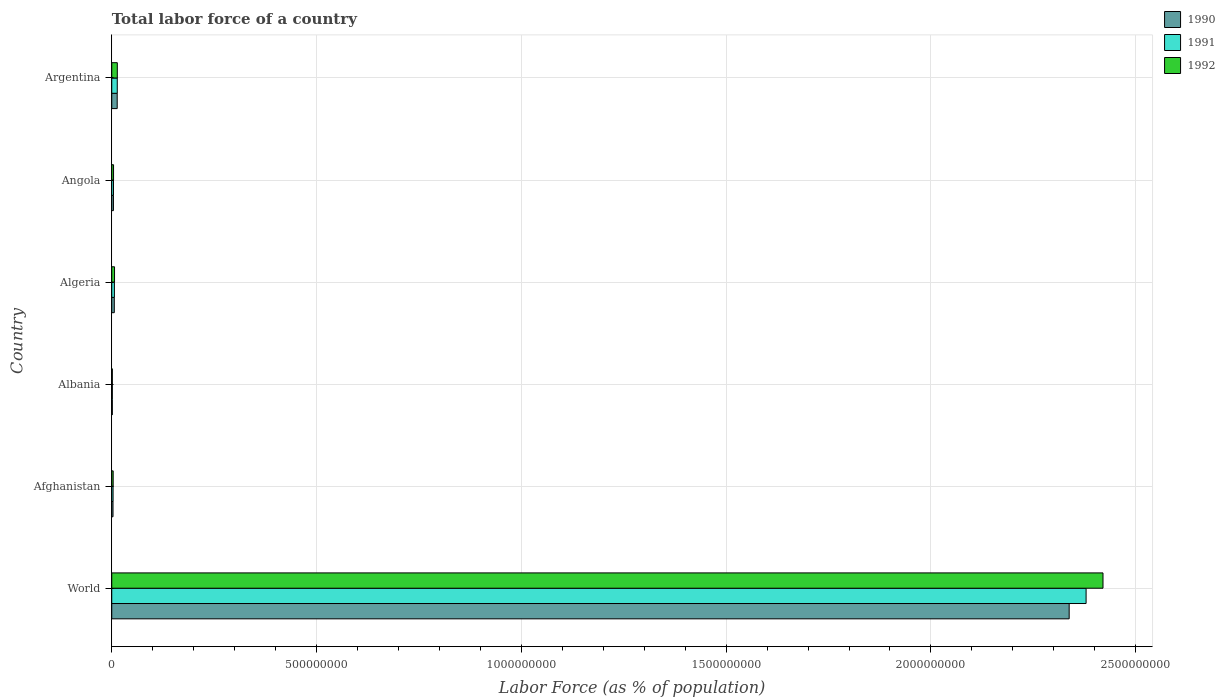How many different coloured bars are there?
Keep it short and to the point. 3. How many groups of bars are there?
Make the answer very short. 6. Are the number of bars per tick equal to the number of legend labels?
Your answer should be very brief. Yes. Are the number of bars on each tick of the Y-axis equal?
Offer a very short reply. Yes. How many bars are there on the 4th tick from the top?
Offer a terse response. 3. What is the label of the 4th group of bars from the top?
Ensure brevity in your answer.  Albania. What is the percentage of labor force in 1990 in World?
Your answer should be compact. 2.34e+09. Across all countries, what is the maximum percentage of labor force in 1992?
Your response must be concise. 2.42e+09. Across all countries, what is the minimum percentage of labor force in 1990?
Give a very brief answer. 1.42e+06. In which country was the percentage of labor force in 1992 minimum?
Provide a short and direct response. Albania. What is the total percentage of labor force in 1991 in the graph?
Your answer should be very brief. 2.41e+09. What is the difference between the percentage of labor force in 1991 in Afghanistan and that in Albania?
Offer a terse response. 1.84e+06. What is the difference between the percentage of labor force in 1991 in World and the percentage of labor force in 1992 in Angola?
Provide a short and direct response. 2.37e+09. What is the average percentage of labor force in 1990 per country?
Your response must be concise. 3.94e+08. What is the difference between the percentage of labor force in 1992 and percentage of labor force in 1991 in Angola?
Offer a terse response. 1.55e+05. What is the ratio of the percentage of labor force in 1992 in Afghanistan to that in Albania?
Your response must be concise. 2.47. Is the percentage of labor force in 1991 in Angola less than that in Argentina?
Make the answer very short. Yes. What is the difference between the highest and the second highest percentage of labor force in 1992?
Your answer should be very brief. 2.41e+09. What is the difference between the highest and the lowest percentage of labor force in 1992?
Provide a short and direct response. 2.42e+09. Is it the case that in every country, the sum of the percentage of labor force in 1991 and percentage of labor force in 1992 is greater than the percentage of labor force in 1990?
Provide a succinct answer. Yes. How many bars are there?
Your answer should be very brief. 18. Are all the bars in the graph horizontal?
Keep it short and to the point. Yes. How many countries are there in the graph?
Offer a terse response. 6. Are the values on the major ticks of X-axis written in scientific E-notation?
Ensure brevity in your answer.  No. Does the graph contain any zero values?
Give a very brief answer. No. Does the graph contain grids?
Your answer should be very brief. Yes. What is the title of the graph?
Provide a short and direct response. Total labor force of a country. Does "1982" appear as one of the legend labels in the graph?
Your response must be concise. No. What is the label or title of the X-axis?
Provide a short and direct response. Labor Force (as % of population). What is the Labor Force (as % of population) in 1990 in World?
Ensure brevity in your answer.  2.34e+09. What is the Labor Force (as % of population) of 1991 in World?
Offer a terse response. 2.38e+09. What is the Labor Force (as % of population) in 1992 in World?
Your answer should be compact. 2.42e+09. What is the Labor Force (as % of population) of 1990 in Afghanistan?
Provide a short and direct response. 3.08e+06. What is the Labor Force (as % of population) of 1991 in Afghanistan?
Ensure brevity in your answer.  3.26e+06. What is the Labor Force (as % of population) of 1992 in Afghanistan?
Ensure brevity in your answer.  3.50e+06. What is the Labor Force (as % of population) in 1990 in Albania?
Your answer should be compact. 1.42e+06. What is the Labor Force (as % of population) in 1991 in Albania?
Give a very brief answer. 1.43e+06. What is the Labor Force (as % of population) in 1992 in Albania?
Ensure brevity in your answer.  1.42e+06. What is the Labor Force (as % of population) of 1990 in Algeria?
Ensure brevity in your answer.  6.21e+06. What is the Labor Force (as % of population) in 1991 in Algeria?
Your response must be concise. 6.50e+06. What is the Labor Force (as % of population) in 1992 in Algeria?
Offer a terse response. 6.81e+06. What is the Labor Force (as % of population) of 1990 in Angola?
Keep it short and to the point. 4.12e+06. What is the Labor Force (as % of population) of 1991 in Angola?
Your answer should be compact. 4.24e+06. What is the Labor Force (as % of population) of 1992 in Angola?
Provide a succinct answer. 4.40e+06. What is the Labor Force (as % of population) in 1990 in Argentina?
Offer a very short reply. 1.33e+07. What is the Labor Force (as % of population) of 1991 in Argentina?
Offer a terse response. 1.35e+07. What is the Labor Force (as % of population) of 1992 in Argentina?
Provide a succinct answer. 1.36e+07. Across all countries, what is the maximum Labor Force (as % of population) in 1990?
Offer a very short reply. 2.34e+09. Across all countries, what is the maximum Labor Force (as % of population) of 1991?
Provide a succinct answer. 2.38e+09. Across all countries, what is the maximum Labor Force (as % of population) in 1992?
Give a very brief answer. 2.42e+09. Across all countries, what is the minimum Labor Force (as % of population) in 1990?
Your answer should be very brief. 1.42e+06. Across all countries, what is the minimum Labor Force (as % of population) in 1991?
Make the answer very short. 1.43e+06. Across all countries, what is the minimum Labor Force (as % of population) of 1992?
Offer a very short reply. 1.42e+06. What is the total Labor Force (as % of population) in 1990 in the graph?
Ensure brevity in your answer.  2.37e+09. What is the total Labor Force (as % of population) of 1991 in the graph?
Your answer should be very brief. 2.41e+09. What is the total Labor Force (as % of population) of 1992 in the graph?
Keep it short and to the point. 2.45e+09. What is the difference between the Labor Force (as % of population) of 1990 in World and that in Afghanistan?
Offer a terse response. 2.33e+09. What is the difference between the Labor Force (as % of population) in 1991 in World and that in Afghanistan?
Offer a very short reply. 2.38e+09. What is the difference between the Labor Force (as % of population) of 1992 in World and that in Afghanistan?
Keep it short and to the point. 2.42e+09. What is the difference between the Labor Force (as % of population) of 1990 in World and that in Albania?
Provide a succinct answer. 2.34e+09. What is the difference between the Labor Force (as % of population) of 1991 in World and that in Albania?
Provide a succinct answer. 2.38e+09. What is the difference between the Labor Force (as % of population) in 1992 in World and that in Albania?
Make the answer very short. 2.42e+09. What is the difference between the Labor Force (as % of population) of 1990 in World and that in Algeria?
Offer a very short reply. 2.33e+09. What is the difference between the Labor Force (as % of population) in 1991 in World and that in Algeria?
Give a very brief answer. 2.37e+09. What is the difference between the Labor Force (as % of population) of 1992 in World and that in Algeria?
Keep it short and to the point. 2.41e+09. What is the difference between the Labor Force (as % of population) of 1990 in World and that in Angola?
Your answer should be compact. 2.33e+09. What is the difference between the Labor Force (as % of population) in 1991 in World and that in Angola?
Your answer should be compact. 2.37e+09. What is the difference between the Labor Force (as % of population) of 1992 in World and that in Angola?
Make the answer very short. 2.42e+09. What is the difference between the Labor Force (as % of population) of 1990 in World and that in Argentina?
Keep it short and to the point. 2.32e+09. What is the difference between the Labor Force (as % of population) in 1991 in World and that in Argentina?
Offer a very short reply. 2.37e+09. What is the difference between the Labor Force (as % of population) in 1992 in World and that in Argentina?
Offer a very short reply. 2.41e+09. What is the difference between the Labor Force (as % of population) in 1990 in Afghanistan and that in Albania?
Keep it short and to the point. 1.66e+06. What is the difference between the Labor Force (as % of population) of 1991 in Afghanistan and that in Albania?
Offer a terse response. 1.84e+06. What is the difference between the Labor Force (as % of population) in 1992 in Afghanistan and that in Albania?
Give a very brief answer. 2.08e+06. What is the difference between the Labor Force (as % of population) of 1990 in Afghanistan and that in Algeria?
Offer a terse response. -3.13e+06. What is the difference between the Labor Force (as % of population) in 1991 in Afghanistan and that in Algeria?
Offer a very short reply. -3.24e+06. What is the difference between the Labor Force (as % of population) of 1992 in Afghanistan and that in Algeria?
Your answer should be very brief. -3.31e+06. What is the difference between the Labor Force (as % of population) of 1990 in Afghanistan and that in Angola?
Ensure brevity in your answer.  -1.03e+06. What is the difference between the Labor Force (as % of population) in 1991 in Afghanistan and that in Angola?
Your answer should be very brief. -9.77e+05. What is the difference between the Labor Force (as % of population) of 1992 in Afghanistan and that in Angola?
Provide a short and direct response. -8.99e+05. What is the difference between the Labor Force (as % of population) in 1990 in Afghanistan and that in Argentina?
Keep it short and to the point. -1.02e+07. What is the difference between the Labor Force (as % of population) in 1991 in Afghanistan and that in Argentina?
Provide a succinct answer. -1.02e+07. What is the difference between the Labor Force (as % of population) of 1992 in Afghanistan and that in Argentina?
Make the answer very short. -1.01e+07. What is the difference between the Labor Force (as % of population) of 1990 in Albania and that in Algeria?
Your answer should be compact. -4.79e+06. What is the difference between the Labor Force (as % of population) of 1991 in Albania and that in Algeria?
Your answer should be compact. -5.08e+06. What is the difference between the Labor Force (as % of population) of 1992 in Albania and that in Algeria?
Provide a short and direct response. -5.39e+06. What is the difference between the Labor Force (as % of population) in 1990 in Albania and that in Angola?
Your response must be concise. -2.70e+06. What is the difference between the Labor Force (as % of population) of 1991 in Albania and that in Angola?
Your answer should be compact. -2.81e+06. What is the difference between the Labor Force (as % of population) of 1992 in Albania and that in Angola?
Make the answer very short. -2.98e+06. What is the difference between the Labor Force (as % of population) in 1990 in Albania and that in Argentina?
Your answer should be very brief. -1.19e+07. What is the difference between the Labor Force (as % of population) of 1991 in Albania and that in Argentina?
Ensure brevity in your answer.  -1.20e+07. What is the difference between the Labor Force (as % of population) in 1992 in Albania and that in Argentina?
Provide a succinct answer. -1.22e+07. What is the difference between the Labor Force (as % of population) in 1990 in Algeria and that in Angola?
Your response must be concise. 2.09e+06. What is the difference between the Labor Force (as % of population) of 1991 in Algeria and that in Angola?
Provide a short and direct response. 2.26e+06. What is the difference between the Labor Force (as % of population) of 1992 in Algeria and that in Angola?
Provide a succinct answer. 2.42e+06. What is the difference between the Labor Force (as % of population) of 1990 in Algeria and that in Argentina?
Offer a terse response. -7.12e+06. What is the difference between the Labor Force (as % of population) in 1991 in Algeria and that in Argentina?
Offer a very short reply. -6.95e+06. What is the difference between the Labor Force (as % of population) in 1992 in Algeria and that in Argentina?
Your answer should be compact. -6.79e+06. What is the difference between the Labor Force (as % of population) in 1990 in Angola and that in Argentina?
Keep it short and to the point. -9.21e+06. What is the difference between the Labor Force (as % of population) of 1991 in Angola and that in Argentina?
Ensure brevity in your answer.  -9.21e+06. What is the difference between the Labor Force (as % of population) in 1992 in Angola and that in Argentina?
Make the answer very short. -9.21e+06. What is the difference between the Labor Force (as % of population) in 1990 in World and the Labor Force (as % of population) in 1991 in Afghanistan?
Provide a short and direct response. 2.33e+09. What is the difference between the Labor Force (as % of population) in 1990 in World and the Labor Force (as % of population) in 1992 in Afghanistan?
Provide a short and direct response. 2.33e+09. What is the difference between the Labor Force (as % of population) in 1991 in World and the Labor Force (as % of population) in 1992 in Afghanistan?
Your answer should be very brief. 2.38e+09. What is the difference between the Labor Force (as % of population) of 1990 in World and the Labor Force (as % of population) of 1991 in Albania?
Your answer should be very brief. 2.34e+09. What is the difference between the Labor Force (as % of population) in 1990 in World and the Labor Force (as % of population) in 1992 in Albania?
Provide a short and direct response. 2.34e+09. What is the difference between the Labor Force (as % of population) of 1991 in World and the Labor Force (as % of population) of 1992 in Albania?
Ensure brevity in your answer.  2.38e+09. What is the difference between the Labor Force (as % of population) of 1990 in World and the Labor Force (as % of population) of 1991 in Algeria?
Provide a short and direct response. 2.33e+09. What is the difference between the Labor Force (as % of population) of 1990 in World and the Labor Force (as % of population) of 1992 in Algeria?
Offer a very short reply. 2.33e+09. What is the difference between the Labor Force (as % of population) of 1991 in World and the Labor Force (as % of population) of 1992 in Algeria?
Offer a very short reply. 2.37e+09. What is the difference between the Labor Force (as % of population) of 1990 in World and the Labor Force (as % of population) of 1991 in Angola?
Your response must be concise. 2.33e+09. What is the difference between the Labor Force (as % of population) of 1990 in World and the Labor Force (as % of population) of 1992 in Angola?
Your answer should be compact. 2.33e+09. What is the difference between the Labor Force (as % of population) in 1991 in World and the Labor Force (as % of population) in 1992 in Angola?
Provide a short and direct response. 2.37e+09. What is the difference between the Labor Force (as % of population) in 1990 in World and the Labor Force (as % of population) in 1991 in Argentina?
Your answer should be very brief. 2.32e+09. What is the difference between the Labor Force (as % of population) in 1990 in World and the Labor Force (as % of population) in 1992 in Argentina?
Your answer should be compact. 2.32e+09. What is the difference between the Labor Force (as % of population) in 1991 in World and the Labor Force (as % of population) in 1992 in Argentina?
Provide a short and direct response. 2.37e+09. What is the difference between the Labor Force (as % of population) in 1990 in Afghanistan and the Labor Force (as % of population) in 1991 in Albania?
Your answer should be very brief. 1.66e+06. What is the difference between the Labor Force (as % of population) in 1990 in Afghanistan and the Labor Force (as % of population) in 1992 in Albania?
Your answer should be compact. 1.67e+06. What is the difference between the Labor Force (as % of population) in 1991 in Afghanistan and the Labor Force (as % of population) in 1992 in Albania?
Give a very brief answer. 1.85e+06. What is the difference between the Labor Force (as % of population) of 1990 in Afghanistan and the Labor Force (as % of population) of 1991 in Algeria?
Keep it short and to the point. -3.42e+06. What is the difference between the Labor Force (as % of population) in 1990 in Afghanistan and the Labor Force (as % of population) in 1992 in Algeria?
Keep it short and to the point. -3.73e+06. What is the difference between the Labor Force (as % of population) in 1991 in Afghanistan and the Labor Force (as % of population) in 1992 in Algeria?
Keep it short and to the point. -3.55e+06. What is the difference between the Labor Force (as % of population) in 1990 in Afghanistan and the Labor Force (as % of population) in 1991 in Angola?
Provide a short and direct response. -1.16e+06. What is the difference between the Labor Force (as % of population) of 1990 in Afghanistan and the Labor Force (as % of population) of 1992 in Angola?
Give a very brief answer. -1.31e+06. What is the difference between the Labor Force (as % of population) of 1991 in Afghanistan and the Labor Force (as % of population) of 1992 in Angola?
Provide a short and direct response. -1.13e+06. What is the difference between the Labor Force (as % of population) in 1990 in Afghanistan and the Labor Force (as % of population) in 1991 in Argentina?
Offer a very short reply. -1.04e+07. What is the difference between the Labor Force (as % of population) of 1990 in Afghanistan and the Labor Force (as % of population) of 1992 in Argentina?
Make the answer very short. -1.05e+07. What is the difference between the Labor Force (as % of population) of 1991 in Afghanistan and the Labor Force (as % of population) of 1992 in Argentina?
Offer a terse response. -1.03e+07. What is the difference between the Labor Force (as % of population) in 1990 in Albania and the Labor Force (as % of population) in 1991 in Algeria?
Your answer should be very brief. -5.08e+06. What is the difference between the Labor Force (as % of population) in 1990 in Albania and the Labor Force (as % of population) in 1992 in Algeria?
Provide a short and direct response. -5.39e+06. What is the difference between the Labor Force (as % of population) in 1991 in Albania and the Labor Force (as % of population) in 1992 in Algeria?
Your response must be concise. -5.38e+06. What is the difference between the Labor Force (as % of population) of 1990 in Albania and the Labor Force (as % of population) of 1991 in Angola?
Ensure brevity in your answer.  -2.82e+06. What is the difference between the Labor Force (as % of population) in 1990 in Albania and the Labor Force (as % of population) in 1992 in Angola?
Provide a short and direct response. -2.98e+06. What is the difference between the Labor Force (as % of population) in 1991 in Albania and the Labor Force (as % of population) in 1992 in Angola?
Make the answer very short. -2.97e+06. What is the difference between the Labor Force (as % of population) of 1990 in Albania and the Labor Force (as % of population) of 1991 in Argentina?
Give a very brief answer. -1.20e+07. What is the difference between the Labor Force (as % of population) in 1990 in Albania and the Labor Force (as % of population) in 1992 in Argentina?
Provide a short and direct response. -1.22e+07. What is the difference between the Labor Force (as % of population) in 1991 in Albania and the Labor Force (as % of population) in 1992 in Argentina?
Keep it short and to the point. -1.22e+07. What is the difference between the Labor Force (as % of population) of 1990 in Algeria and the Labor Force (as % of population) of 1991 in Angola?
Provide a succinct answer. 1.97e+06. What is the difference between the Labor Force (as % of population) in 1990 in Algeria and the Labor Force (as % of population) in 1992 in Angola?
Your answer should be compact. 1.82e+06. What is the difference between the Labor Force (as % of population) in 1991 in Algeria and the Labor Force (as % of population) in 1992 in Angola?
Give a very brief answer. 2.11e+06. What is the difference between the Labor Force (as % of population) of 1990 in Algeria and the Labor Force (as % of population) of 1991 in Argentina?
Provide a succinct answer. -7.24e+06. What is the difference between the Labor Force (as % of population) of 1990 in Algeria and the Labor Force (as % of population) of 1992 in Argentina?
Ensure brevity in your answer.  -7.39e+06. What is the difference between the Labor Force (as % of population) of 1991 in Algeria and the Labor Force (as % of population) of 1992 in Argentina?
Offer a very short reply. -7.10e+06. What is the difference between the Labor Force (as % of population) of 1990 in Angola and the Labor Force (as % of population) of 1991 in Argentina?
Your answer should be compact. -9.34e+06. What is the difference between the Labor Force (as % of population) in 1990 in Angola and the Labor Force (as % of population) in 1992 in Argentina?
Give a very brief answer. -9.49e+06. What is the difference between the Labor Force (as % of population) of 1991 in Angola and the Labor Force (as % of population) of 1992 in Argentina?
Your answer should be very brief. -9.36e+06. What is the average Labor Force (as % of population) in 1990 per country?
Keep it short and to the point. 3.94e+08. What is the average Labor Force (as % of population) in 1991 per country?
Give a very brief answer. 4.01e+08. What is the average Labor Force (as % of population) of 1992 per country?
Keep it short and to the point. 4.08e+08. What is the difference between the Labor Force (as % of population) in 1990 and Labor Force (as % of population) in 1991 in World?
Your response must be concise. -4.13e+07. What is the difference between the Labor Force (as % of population) of 1990 and Labor Force (as % of population) of 1992 in World?
Give a very brief answer. -8.26e+07. What is the difference between the Labor Force (as % of population) in 1991 and Labor Force (as % of population) in 1992 in World?
Your response must be concise. -4.13e+07. What is the difference between the Labor Force (as % of population) in 1990 and Labor Force (as % of population) in 1991 in Afghanistan?
Give a very brief answer. -1.80e+05. What is the difference between the Labor Force (as % of population) of 1990 and Labor Force (as % of population) of 1992 in Afghanistan?
Offer a very short reply. -4.13e+05. What is the difference between the Labor Force (as % of population) of 1991 and Labor Force (as % of population) of 1992 in Afghanistan?
Provide a short and direct response. -2.33e+05. What is the difference between the Labor Force (as % of population) in 1990 and Labor Force (as % of population) in 1991 in Albania?
Provide a succinct answer. -6581. What is the difference between the Labor Force (as % of population) of 1990 and Labor Force (as % of population) of 1992 in Albania?
Give a very brief answer. 2941. What is the difference between the Labor Force (as % of population) of 1991 and Labor Force (as % of population) of 1992 in Albania?
Make the answer very short. 9522. What is the difference between the Labor Force (as % of population) of 1990 and Labor Force (as % of population) of 1991 in Algeria?
Your response must be concise. -2.94e+05. What is the difference between the Labor Force (as % of population) in 1990 and Labor Force (as % of population) in 1992 in Algeria?
Keep it short and to the point. -6.01e+05. What is the difference between the Labor Force (as % of population) in 1991 and Labor Force (as % of population) in 1992 in Algeria?
Your answer should be very brief. -3.07e+05. What is the difference between the Labor Force (as % of population) in 1990 and Labor Force (as % of population) in 1991 in Angola?
Provide a short and direct response. -1.22e+05. What is the difference between the Labor Force (as % of population) in 1990 and Labor Force (as % of population) in 1992 in Angola?
Keep it short and to the point. -2.77e+05. What is the difference between the Labor Force (as % of population) of 1991 and Labor Force (as % of population) of 1992 in Angola?
Keep it short and to the point. -1.55e+05. What is the difference between the Labor Force (as % of population) in 1990 and Labor Force (as % of population) in 1991 in Argentina?
Offer a very short reply. -1.25e+05. What is the difference between the Labor Force (as % of population) of 1990 and Labor Force (as % of population) of 1992 in Argentina?
Offer a very short reply. -2.74e+05. What is the difference between the Labor Force (as % of population) in 1991 and Labor Force (as % of population) in 1992 in Argentina?
Provide a succinct answer. -1.50e+05. What is the ratio of the Labor Force (as % of population) in 1990 in World to that in Afghanistan?
Your response must be concise. 758.09. What is the ratio of the Labor Force (as % of population) in 1991 in World to that in Afghanistan?
Provide a short and direct response. 728.92. What is the ratio of the Labor Force (as % of population) in 1992 in World to that in Afghanistan?
Provide a succinct answer. 692.14. What is the ratio of the Labor Force (as % of population) in 1990 in World to that in Albania?
Ensure brevity in your answer.  1646.06. What is the ratio of the Labor Force (as % of population) of 1991 in World to that in Albania?
Offer a very short reply. 1667.42. What is the ratio of the Labor Force (as % of population) of 1992 in World to that in Albania?
Keep it short and to the point. 1707.73. What is the ratio of the Labor Force (as % of population) of 1990 in World to that in Algeria?
Offer a terse response. 376.37. What is the ratio of the Labor Force (as % of population) of 1991 in World to that in Algeria?
Your answer should be compact. 365.71. What is the ratio of the Labor Force (as % of population) in 1992 in World to that in Algeria?
Provide a short and direct response. 355.31. What is the ratio of the Labor Force (as % of population) of 1990 in World to that in Angola?
Offer a terse response. 567.6. What is the ratio of the Labor Force (as % of population) of 1991 in World to that in Angola?
Provide a short and direct response. 560.97. What is the ratio of the Labor Force (as % of population) in 1992 in World to that in Angola?
Offer a terse response. 550.64. What is the ratio of the Labor Force (as % of population) in 1990 in World to that in Argentina?
Your answer should be compact. 175.35. What is the ratio of the Labor Force (as % of population) of 1991 in World to that in Argentina?
Make the answer very short. 176.79. What is the ratio of the Labor Force (as % of population) of 1992 in World to that in Argentina?
Give a very brief answer. 177.88. What is the ratio of the Labor Force (as % of population) in 1990 in Afghanistan to that in Albania?
Keep it short and to the point. 2.17. What is the ratio of the Labor Force (as % of population) of 1991 in Afghanistan to that in Albania?
Your answer should be compact. 2.29. What is the ratio of the Labor Force (as % of population) in 1992 in Afghanistan to that in Albania?
Offer a very short reply. 2.47. What is the ratio of the Labor Force (as % of population) in 1990 in Afghanistan to that in Algeria?
Keep it short and to the point. 0.5. What is the ratio of the Labor Force (as % of population) in 1991 in Afghanistan to that in Algeria?
Offer a terse response. 0.5. What is the ratio of the Labor Force (as % of population) of 1992 in Afghanistan to that in Algeria?
Keep it short and to the point. 0.51. What is the ratio of the Labor Force (as % of population) in 1990 in Afghanistan to that in Angola?
Your answer should be compact. 0.75. What is the ratio of the Labor Force (as % of population) in 1991 in Afghanistan to that in Angola?
Ensure brevity in your answer.  0.77. What is the ratio of the Labor Force (as % of population) of 1992 in Afghanistan to that in Angola?
Give a very brief answer. 0.8. What is the ratio of the Labor Force (as % of population) in 1990 in Afghanistan to that in Argentina?
Keep it short and to the point. 0.23. What is the ratio of the Labor Force (as % of population) of 1991 in Afghanistan to that in Argentina?
Give a very brief answer. 0.24. What is the ratio of the Labor Force (as % of population) of 1992 in Afghanistan to that in Argentina?
Your answer should be very brief. 0.26. What is the ratio of the Labor Force (as % of population) in 1990 in Albania to that in Algeria?
Provide a short and direct response. 0.23. What is the ratio of the Labor Force (as % of population) in 1991 in Albania to that in Algeria?
Keep it short and to the point. 0.22. What is the ratio of the Labor Force (as % of population) of 1992 in Albania to that in Algeria?
Your answer should be very brief. 0.21. What is the ratio of the Labor Force (as % of population) of 1990 in Albania to that in Angola?
Your answer should be compact. 0.34. What is the ratio of the Labor Force (as % of population) in 1991 in Albania to that in Angola?
Your answer should be compact. 0.34. What is the ratio of the Labor Force (as % of population) of 1992 in Albania to that in Angola?
Give a very brief answer. 0.32. What is the ratio of the Labor Force (as % of population) in 1990 in Albania to that in Argentina?
Keep it short and to the point. 0.11. What is the ratio of the Labor Force (as % of population) in 1991 in Albania to that in Argentina?
Ensure brevity in your answer.  0.11. What is the ratio of the Labor Force (as % of population) in 1992 in Albania to that in Argentina?
Provide a succinct answer. 0.1. What is the ratio of the Labor Force (as % of population) of 1990 in Algeria to that in Angola?
Provide a short and direct response. 1.51. What is the ratio of the Labor Force (as % of population) in 1991 in Algeria to that in Angola?
Keep it short and to the point. 1.53. What is the ratio of the Labor Force (as % of population) of 1992 in Algeria to that in Angola?
Your answer should be compact. 1.55. What is the ratio of the Labor Force (as % of population) in 1990 in Algeria to that in Argentina?
Ensure brevity in your answer.  0.47. What is the ratio of the Labor Force (as % of population) in 1991 in Algeria to that in Argentina?
Ensure brevity in your answer.  0.48. What is the ratio of the Labor Force (as % of population) in 1992 in Algeria to that in Argentina?
Offer a very short reply. 0.5. What is the ratio of the Labor Force (as % of population) in 1990 in Angola to that in Argentina?
Make the answer very short. 0.31. What is the ratio of the Labor Force (as % of population) in 1991 in Angola to that in Argentina?
Your response must be concise. 0.32. What is the ratio of the Labor Force (as % of population) of 1992 in Angola to that in Argentina?
Keep it short and to the point. 0.32. What is the difference between the highest and the second highest Labor Force (as % of population) of 1990?
Provide a succinct answer. 2.32e+09. What is the difference between the highest and the second highest Labor Force (as % of population) in 1991?
Your answer should be compact. 2.37e+09. What is the difference between the highest and the second highest Labor Force (as % of population) in 1992?
Your response must be concise. 2.41e+09. What is the difference between the highest and the lowest Labor Force (as % of population) in 1990?
Ensure brevity in your answer.  2.34e+09. What is the difference between the highest and the lowest Labor Force (as % of population) in 1991?
Your response must be concise. 2.38e+09. What is the difference between the highest and the lowest Labor Force (as % of population) in 1992?
Ensure brevity in your answer.  2.42e+09. 